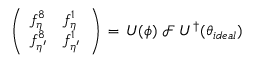<formula> <loc_0><loc_0><loc_500><loc_500>\left ( \begin{array} { l l } { { f _ { \eta } ^ { 8 } } } & { { f _ { \eta } ^ { 1 } } } \\ { { f _ { \eta ^ { \prime } } ^ { 8 } } } & { { f _ { \eta ^ { \prime } } ^ { 1 } } } \end{array} \right ) \, = \, U ( \phi ) \, { \mathcal { F } } \, U ^ { \dagger } ( \theta _ { i d e a l } )</formula> 